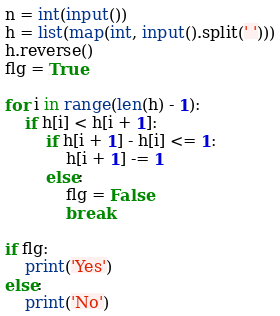<code> <loc_0><loc_0><loc_500><loc_500><_Python_>n = int(input())
h = list(map(int, input().split(' ')))
h.reverse()
flg = True

for i in range(len(h) - 1):
    if h[i] < h[i + 1]:
        if h[i + 1] - h[i] <= 1:
            h[i + 1] -= 1
        else:
            flg = False
            break

if flg:
    print('Yes')
else:
    print('No')</code> 